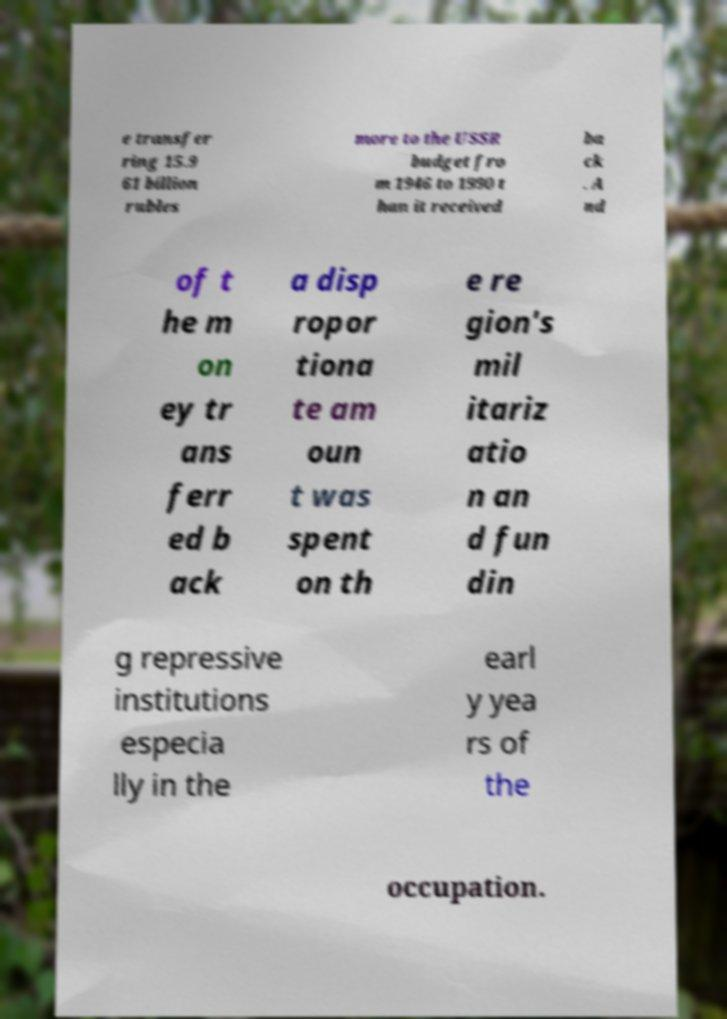Please read and relay the text visible in this image. What does it say? e transfer ring 15.9 61 billion rubles more to the USSR budget fro m 1946 to 1990 t han it received ba ck . A nd of t he m on ey tr ans ferr ed b ack a disp ropor tiona te am oun t was spent on th e re gion's mil itariz atio n an d fun din g repressive institutions especia lly in the earl y yea rs of the occupation. 